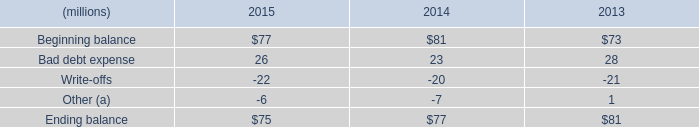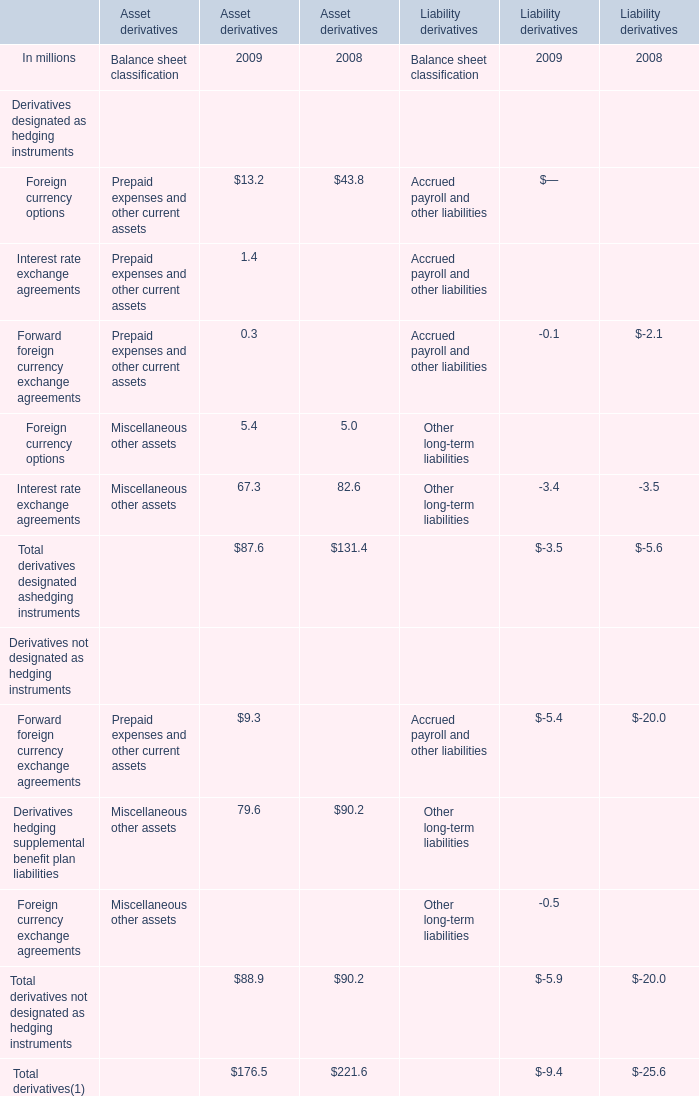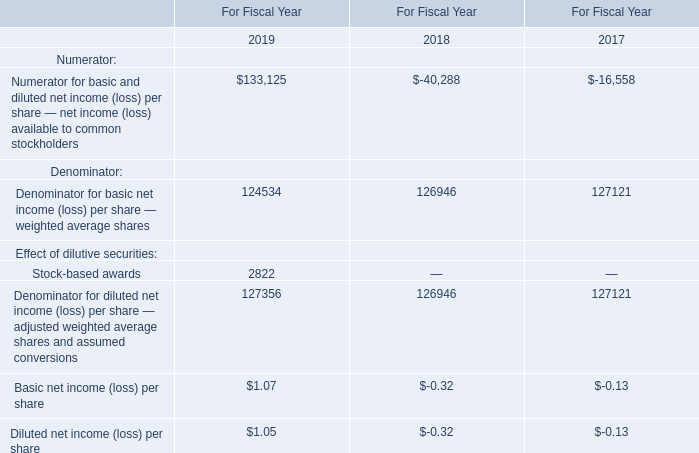what is the growth rate in the balance of allowance for doubtful accounts from 2014 to 2015? 
Computations: ((75 - 77) + 77)
Answer: 75.0. 